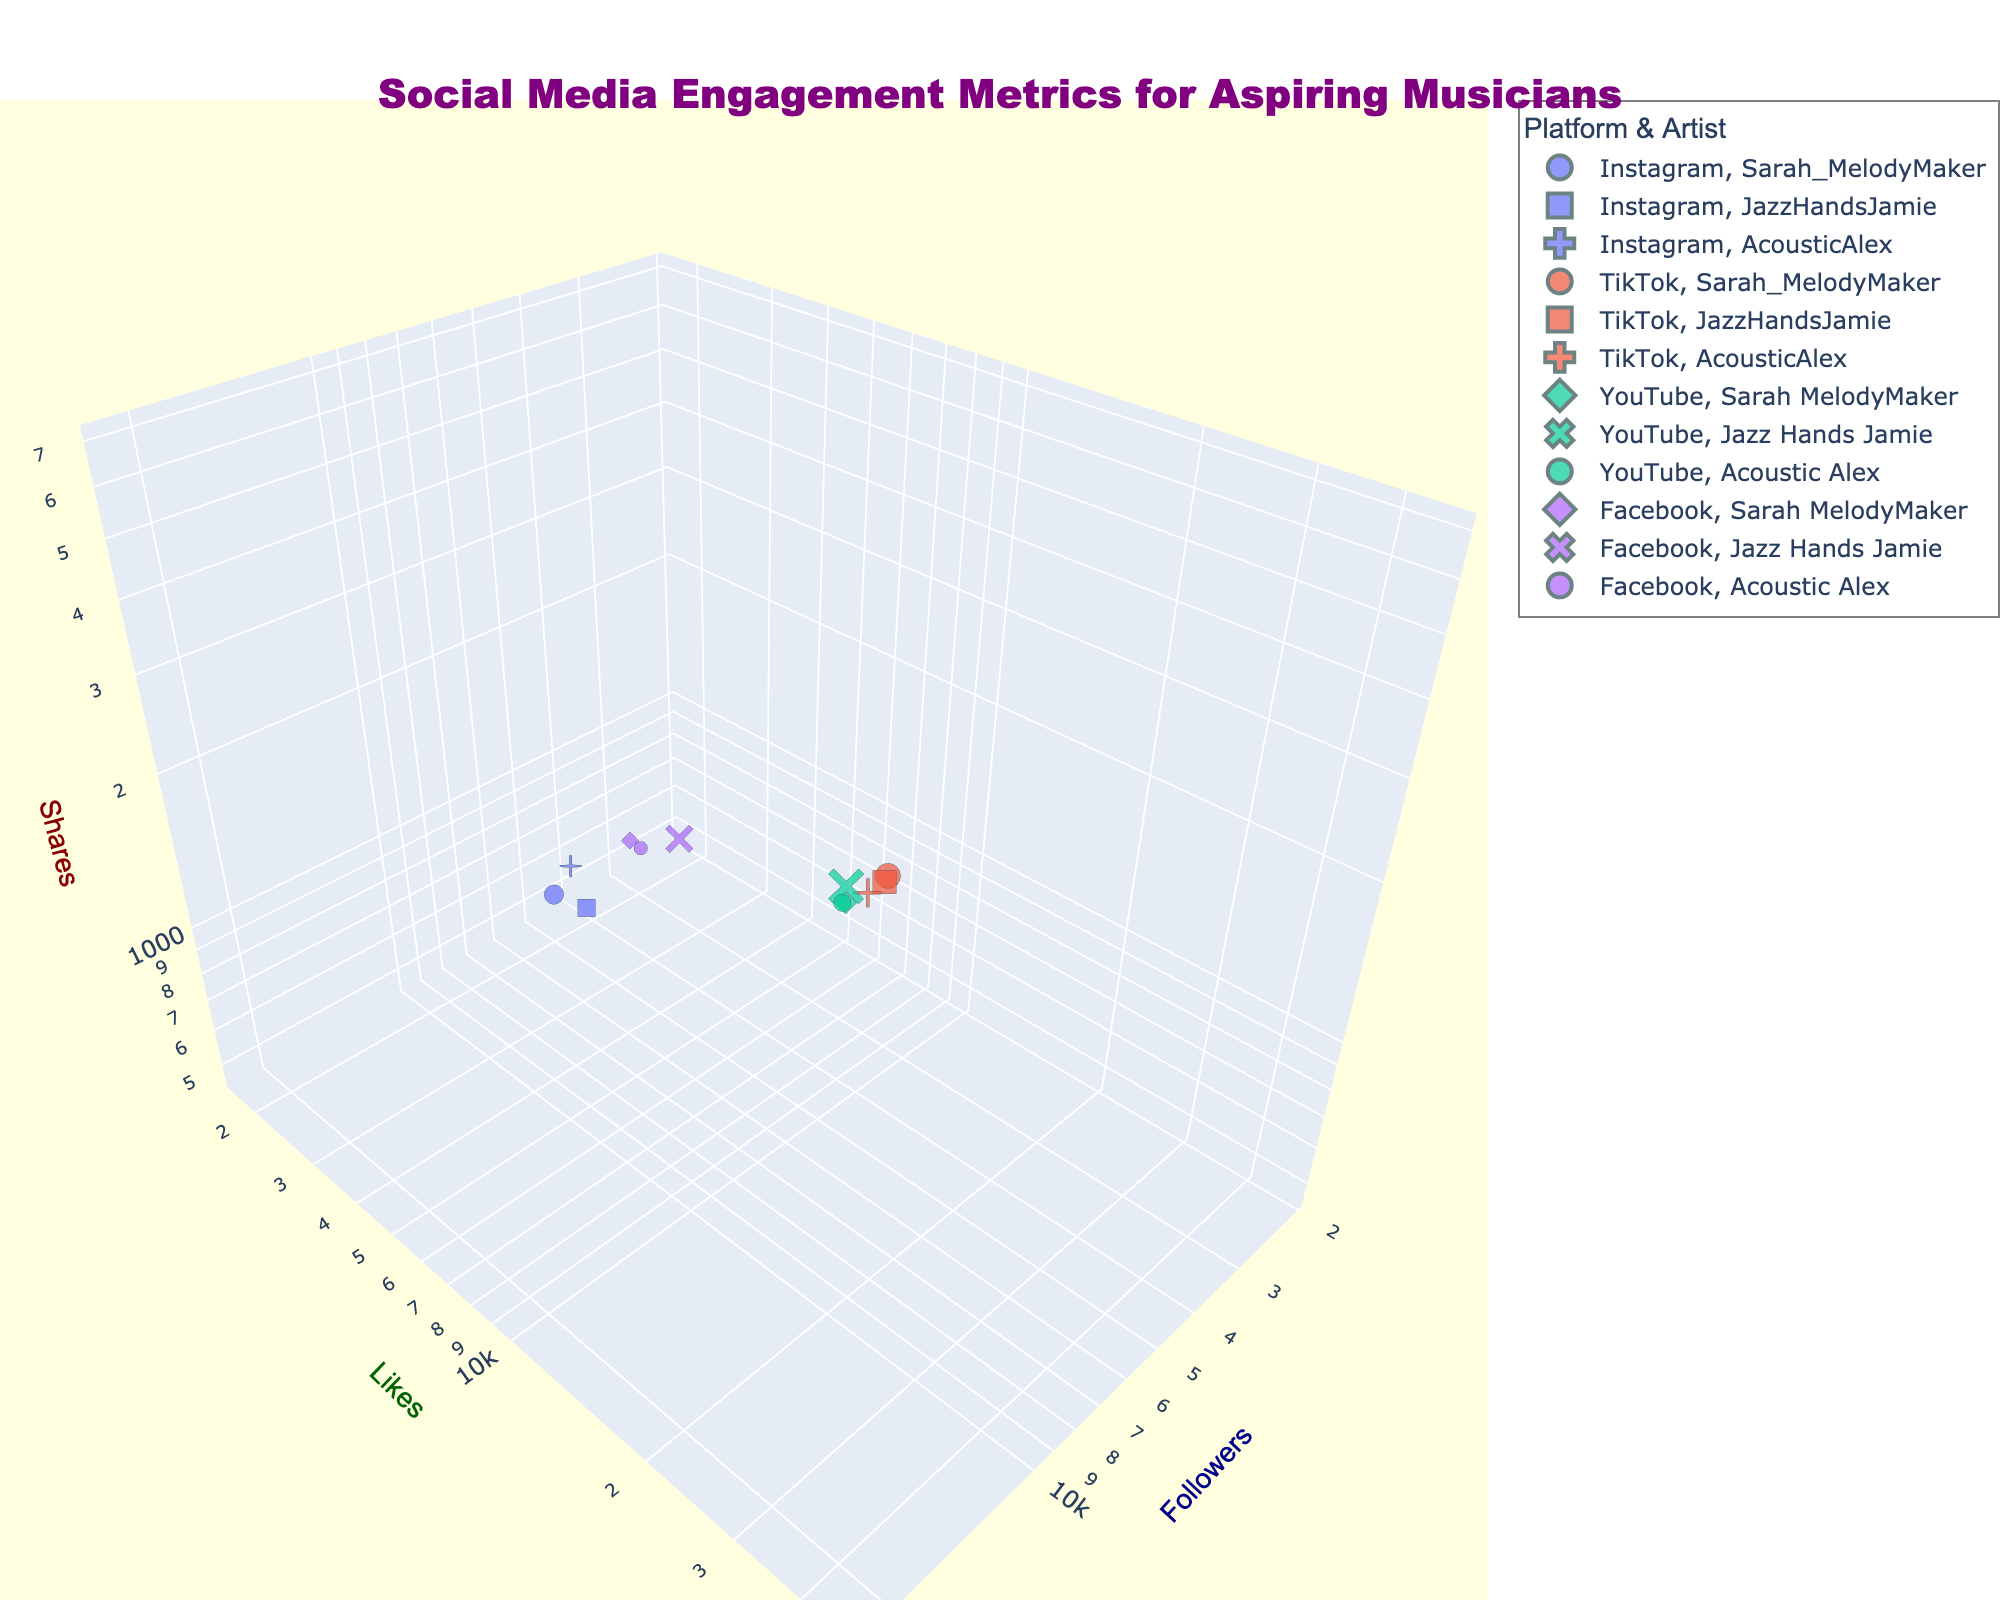What is the title of the figure? The title is a piece of textual information typically located at the top of the chart. Here, the title of the figure is "Social Media Engagement Metrics for Aspiring Musicians".
Answer: Social Media Engagement Metrics for Aspiring Musicians What are the three metrics being compared in the chart? The figure's axes titles indicate the three metrics: Followers, Likes, and Shares. These are log-transformed on their respective axes.
Answer: Followers, Likes, Shares Which platform does Sarah_MelodyMaker have the highest number of followers on? Look at the x-axis (Followers) and find the largest bubble for Sarah_MelodyMaker. The highest is on TikTok at 22,000 followers.
Answer: TikTok What artist has the smallest bubble on YouTube? The bubble size is related to combined metrics. On YouTube, the smallest bubble for an artist is for Jazz Hands Jamie.
Answer: Jazz Hands Jamie Which platform generally shows higher shares for the artists? By examining the z-axis (Shares), TikTok has generally higher shares for all the artists compared to other platforms.
Answer: TikTok What is the difference in the number of shares between Acoustic Alex on Instagram and Facebook? AcousticAlex has 1800 shares on Instagram and 620 on Facebook. The difference is calculated as 1800 - 620.
Answer: 1180 How do the like counts of JazzHandsJamie on TikTok compare to Sarah_MelodyMaker on TikTok? JazzHandsJamie has 28,000 likes on TikTok, while Sarah_MelodyMaker has 45,000 on TikTok. Sarah_MelodyMaker has higher likes.
Answer: Sarah_MelodyMaker has higher likes Which artist has the smallest number of likes on any platform? Check for the lowest value on the y-axis (Likes). The smallest number of likes is found for Jazz Hands Jamie on Facebook with 1800 likes.
Answer: Jazz Hands Jamie on Facebook 